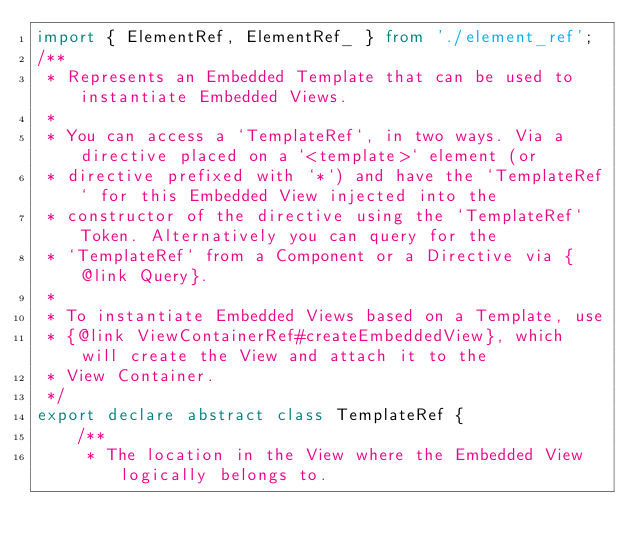<code> <loc_0><loc_0><loc_500><loc_500><_TypeScript_>import { ElementRef, ElementRef_ } from './element_ref';
/**
 * Represents an Embedded Template that can be used to instantiate Embedded Views.
 *
 * You can access a `TemplateRef`, in two ways. Via a directive placed on a `<template>` element (or
 * directive prefixed with `*`) and have the `TemplateRef` for this Embedded View injected into the
 * constructor of the directive using the `TemplateRef` Token. Alternatively you can query for the
 * `TemplateRef` from a Component or a Directive via {@link Query}.
 *
 * To instantiate Embedded Views based on a Template, use
 * {@link ViewContainerRef#createEmbeddedView}, which will create the View and attach it to the
 * View Container.
 */
export declare abstract class TemplateRef {
    /**
     * The location in the View where the Embedded View logically belongs to.</code> 